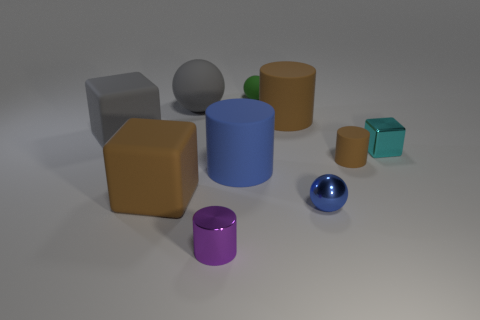Subtract 1 spheres. How many spheres are left? 2 Subtract all tiny spheres. How many spheres are left? 1 Subtract all cubes. How many objects are left? 7 Subtract all purple cylinders. How many cylinders are left? 3 Subtract all small gray spheres. Subtract all small cylinders. How many objects are left? 8 Add 4 large rubber blocks. How many large rubber blocks are left? 6 Add 6 tiny red matte cylinders. How many tiny red matte cylinders exist? 6 Subtract 0 red cylinders. How many objects are left? 10 Subtract all yellow spheres. Subtract all brown cylinders. How many spheres are left? 3 Subtract all green cubes. How many gray balls are left? 1 